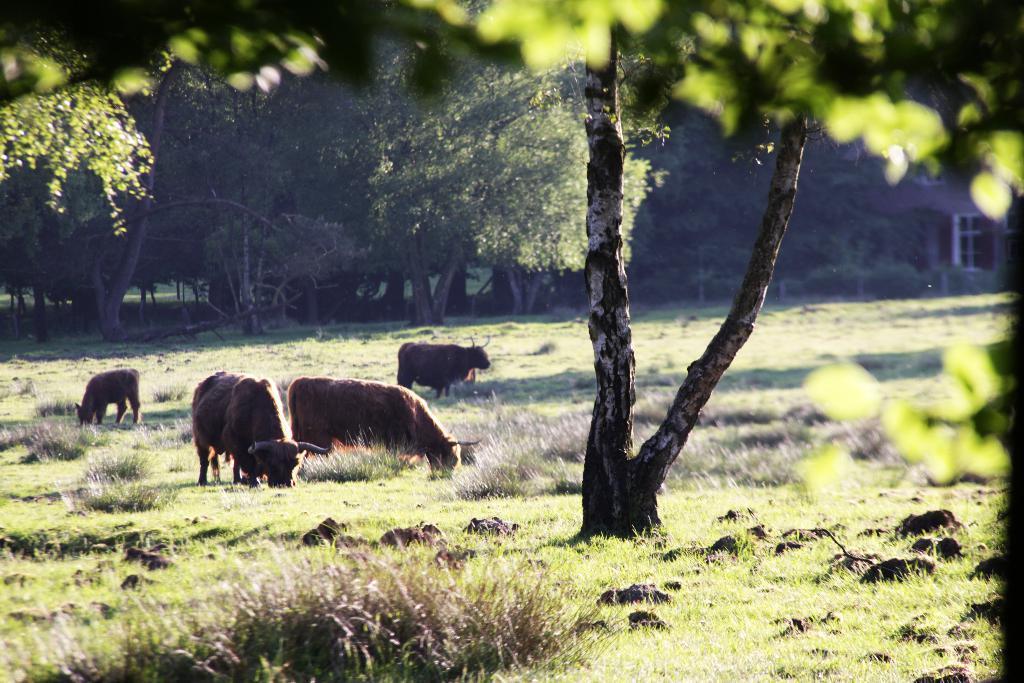In one or two sentences, can you explain what this image depicts? In this image we can see some animals on the ground, there are some plants, trees, stones and grass. 